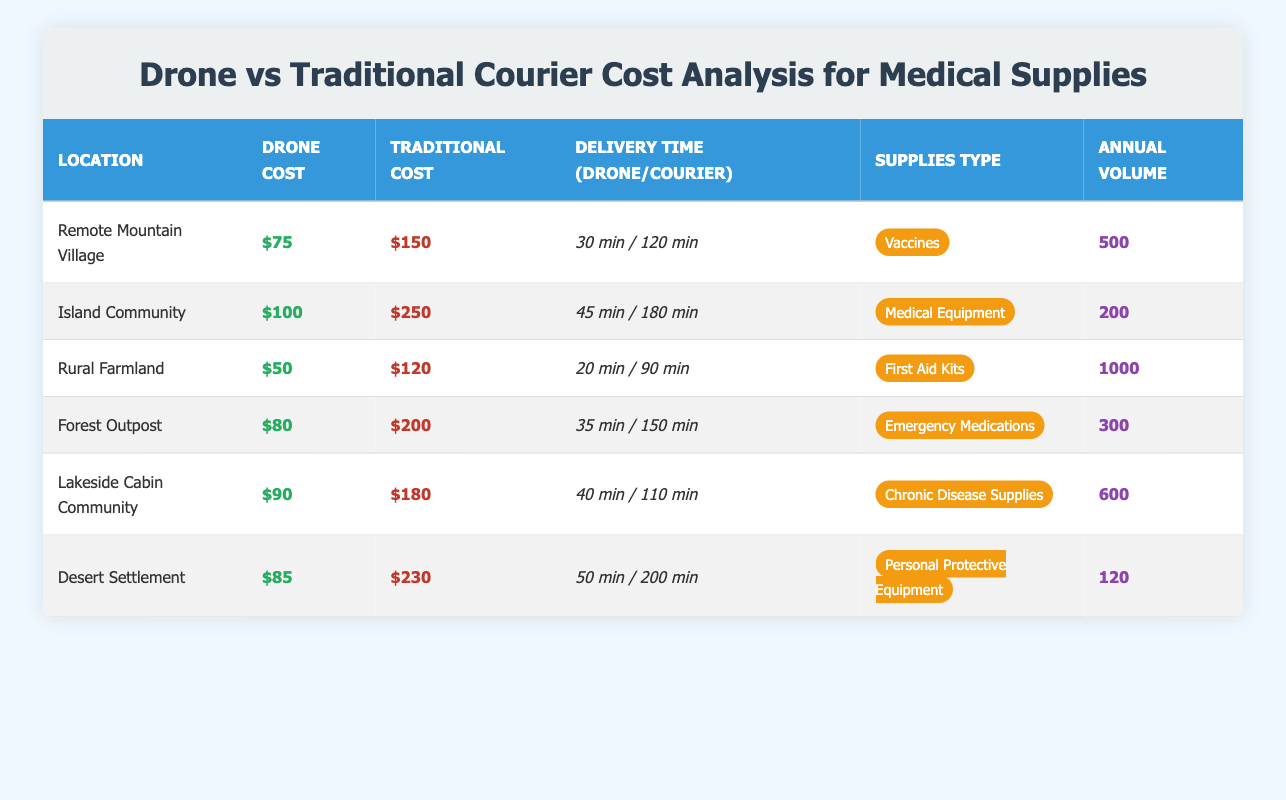What is the delivery time for drones in the Rural Farmland? The table specifies the delivery time for drones in Rural Farmland as 20 minutes.
Answer: 20 minutes Which location has the highest traditional courier cost? The highest traditional courier cost listed in the table is $250 for the Island Community.
Answer: $250 What is the difference in cost between drone delivery and traditional courier services in the Forest Outpost? The drone delivery cost in the Forest Outpost is $80, while the traditional courier cost is $200. The difference is $200 - $80 = $120.
Answer: $120 Are drones cheaper for delivery than traditional courier services in the Desert Settlement? The drone delivery cost is $85, and the traditional courier cost is $230. Since $85 is less than $230, the statement is true.
Answer: Yes What is the average drone delivery cost across all locations listed? To find the average, sum the drone delivery costs: $75 + $100 + $50 + $80 + $90 + $85 = $480. There are 6 locations, so the average is $480 / 6 = $80.
Answer: $80 Which type of supplies has the highest estimated annual volume? The Rural Farmland has the highest estimated annual volume listed at 1000 units for First Aid Kits.
Answer: First Aid Kits What is the average delivery time for traditional courier services across all locations? The delivery times for traditional couriers are 120, 180, 90, 150, 110, and 200 minutes. Summing these gives 120 + 180 + 90 + 150 + 110 + 200 = 950 minutes. Dividing by 6 gives an average of 950 / 6 ≈ 158.33 minutes.
Answer: 158.33 minutes In which location are medical equipment supplies delivered by drone the fastest? The Island Community has a drone delivery time of 45 minutes, which is faster than other locations delivering medical equipment.
Answer: Island Community How much would it cost to deliver 600 chronic disease supplies by drone and courier in Lakeside Cabin Community? The drone delivery cost is $90 and the traditional courier cost is $180. Thus, for 600 supplies, the total cost by drone is 600 * $90 = $54,000 and by courier is 600 * $180 = $108,000.
Answer: $54,000 (drone), $108,000 (courier) Is the delivery time for drones in the Desert Settlement shorter than the delivery time for traditional couriers in the same location? The drone delivery time is 50 minutes, while the traditional courier takes 200 minutes. Since 50 is less than 200, this statement is true.
Answer: Yes 